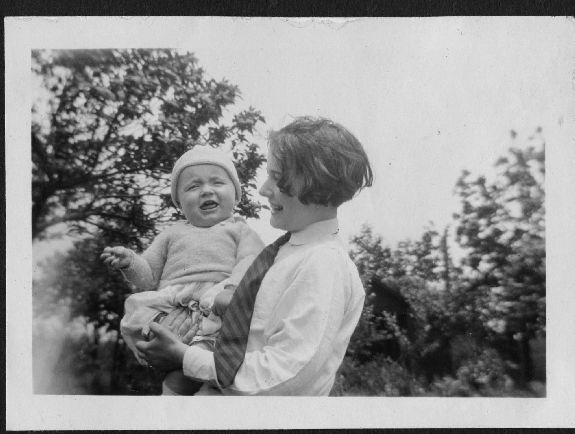Describe the objects in this image and their specific colors. I can see people in black, gray, darkgray, and lightgray tones, people in black, darkgray, gray, and lightgray tones, and tie in black, gray, darkgray, and lightgray tones in this image. 